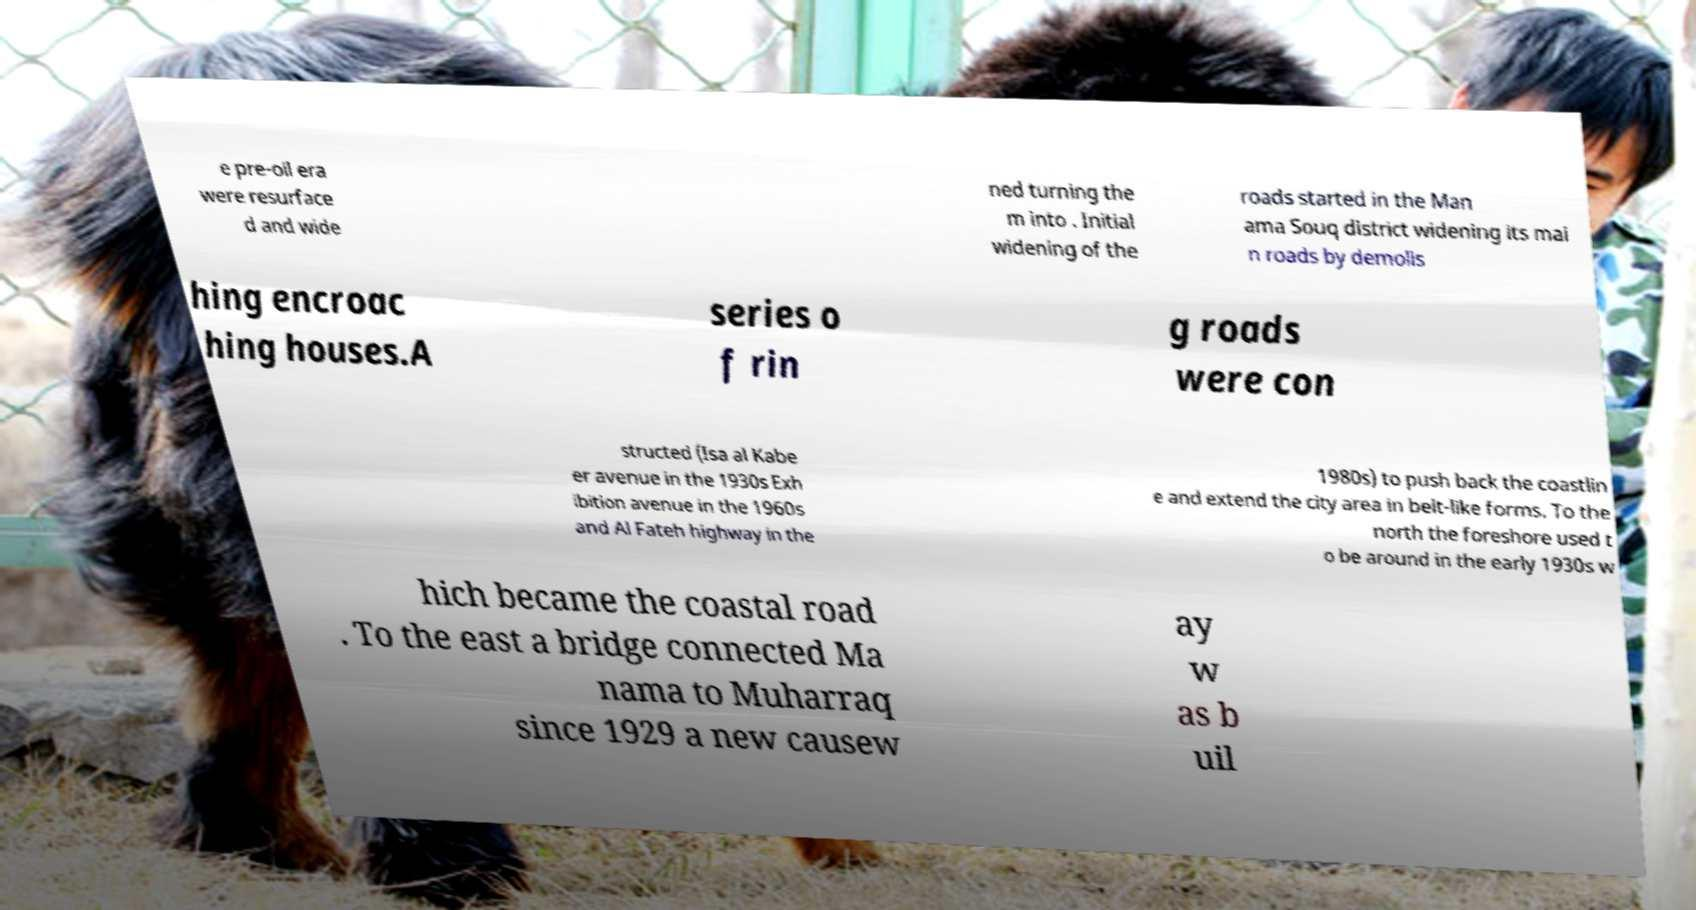For documentation purposes, I need the text within this image transcribed. Could you provide that? e pre-oil era were resurface d and wide ned turning the m into . Initial widening of the roads started in the Man ama Souq district widening its mai n roads by demolis hing encroac hing houses.A series o f rin g roads were con structed (Isa al Kabe er avenue in the 1930s Exh ibition avenue in the 1960s and Al Fateh highway in the 1980s) to push back the coastlin e and extend the city area in belt-like forms. To the north the foreshore used t o be around in the early 1930s w hich became the coastal road . To the east a bridge connected Ma nama to Muharraq since 1929 a new causew ay w as b uil 